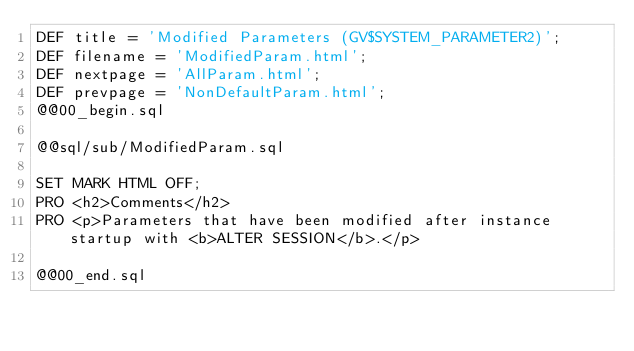<code> <loc_0><loc_0><loc_500><loc_500><_SQL_>DEF title = 'Modified Parameters (GV$SYSTEM_PARAMETER2)';
DEF filename = 'ModifiedParam.html';
DEF nextpage = 'AllParam.html';
DEF prevpage = 'NonDefaultParam.html';
@@00_begin.sql

@@sql/sub/ModifiedParam.sql

SET MARK HTML OFF;
PRO <h2>Comments</h2>
PRO <p>Parameters that have been modified after instance startup with <b>ALTER SESSION</b>.</p>

@@00_end.sql
</code> 